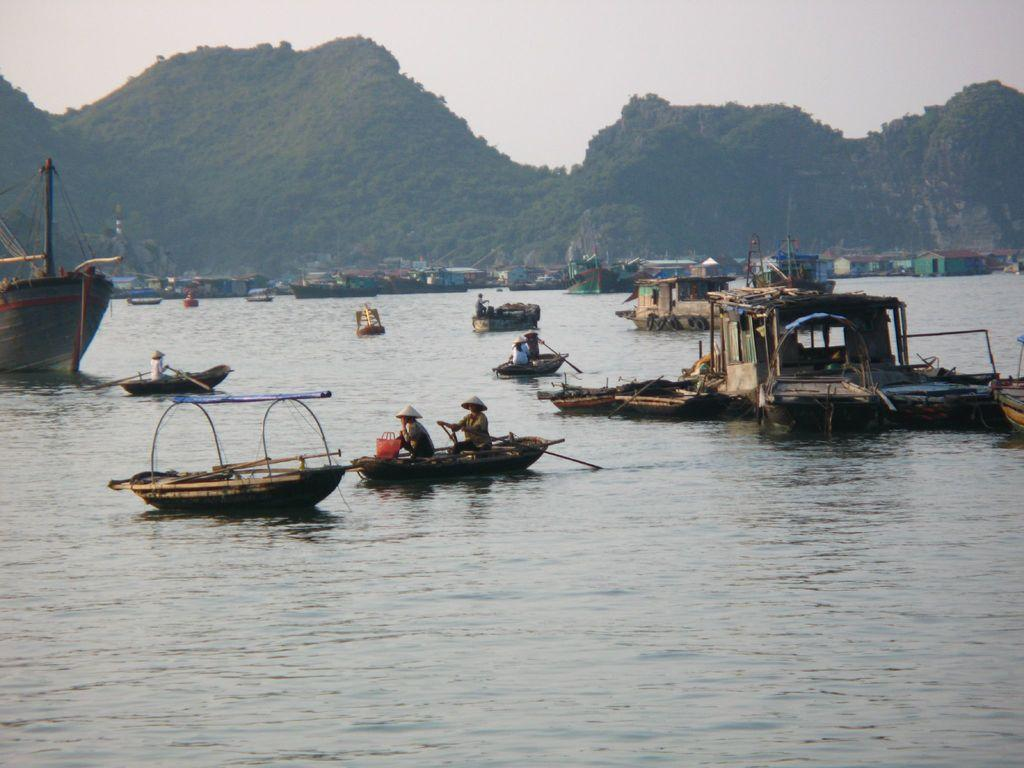What are the people in the image doing? The people in the image are sitting on boats. What are the people using to move the boats? The people are holding paddles. Where are the boats located? The boats are on the water. What can be seen in the background of the image? There are hills and the sky visible in the background of the image. What type of hope can be seen growing on the hills in the image? There is no mention of hope or any plant life in the image; it features people in boats on the water with hills and the sky in the background. 